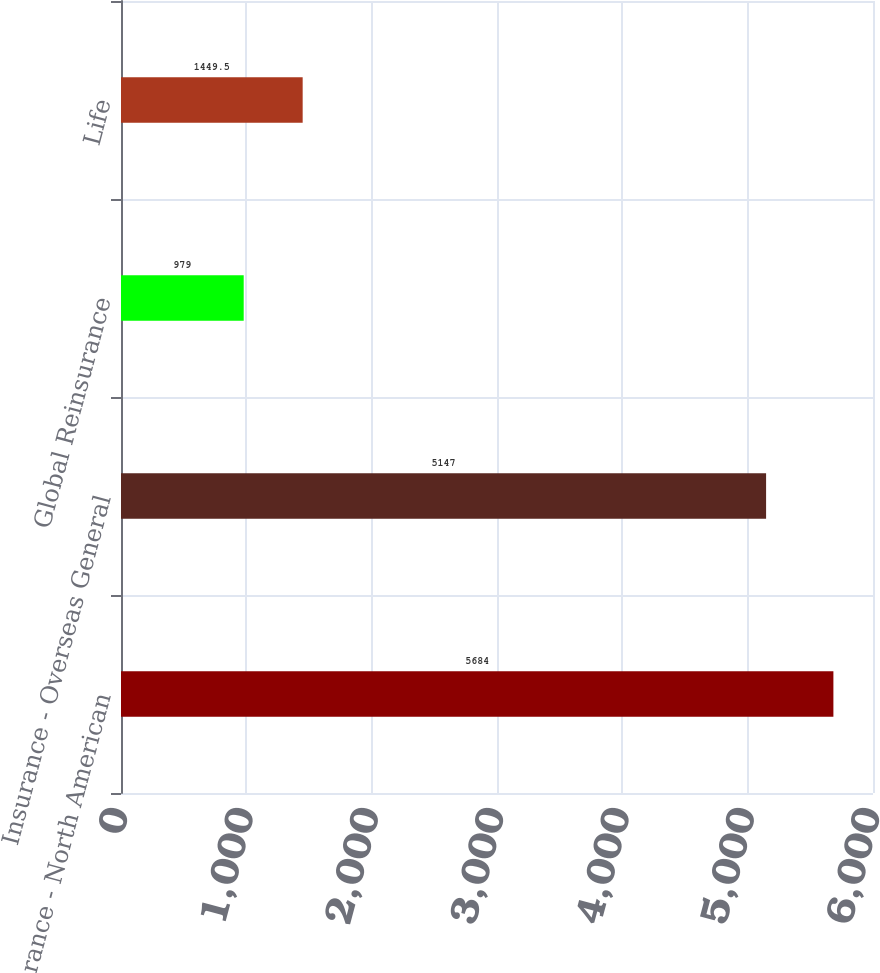Convert chart to OTSL. <chart><loc_0><loc_0><loc_500><loc_500><bar_chart><fcel>Insurance - North American<fcel>Insurance - Overseas General<fcel>Global Reinsurance<fcel>Life<nl><fcel>5684<fcel>5147<fcel>979<fcel>1449.5<nl></chart> 